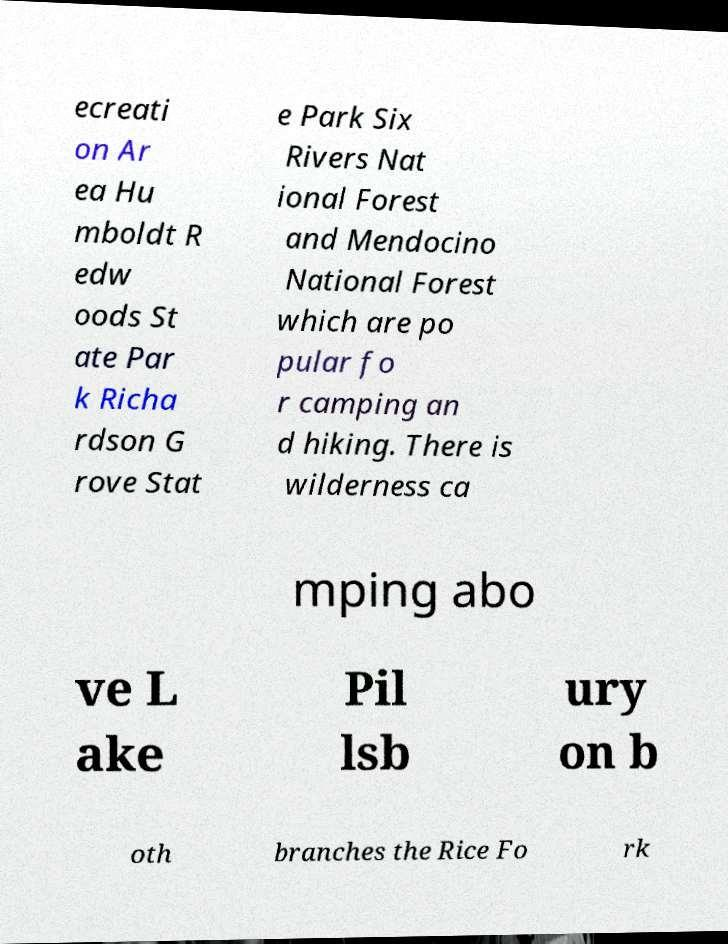Could you extract and type out the text from this image? ecreati on Ar ea Hu mboldt R edw oods St ate Par k Richa rdson G rove Stat e Park Six Rivers Nat ional Forest and Mendocino National Forest which are po pular fo r camping an d hiking. There is wilderness ca mping abo ve L ake Pil lsb ury on b oth branches the Rice Fo rk 